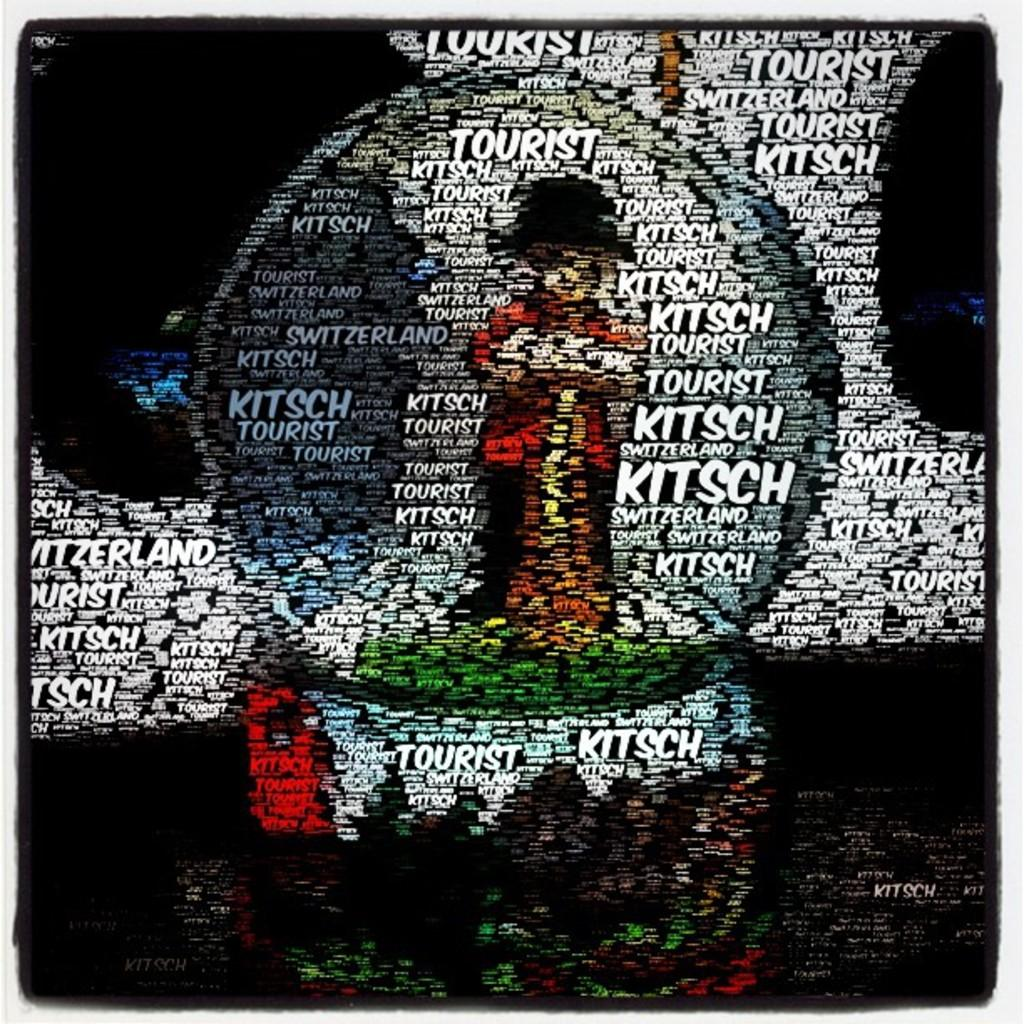Provide a one-sentence caption for the provided image. A language graphic repeatedly shows the word "kitsch". 